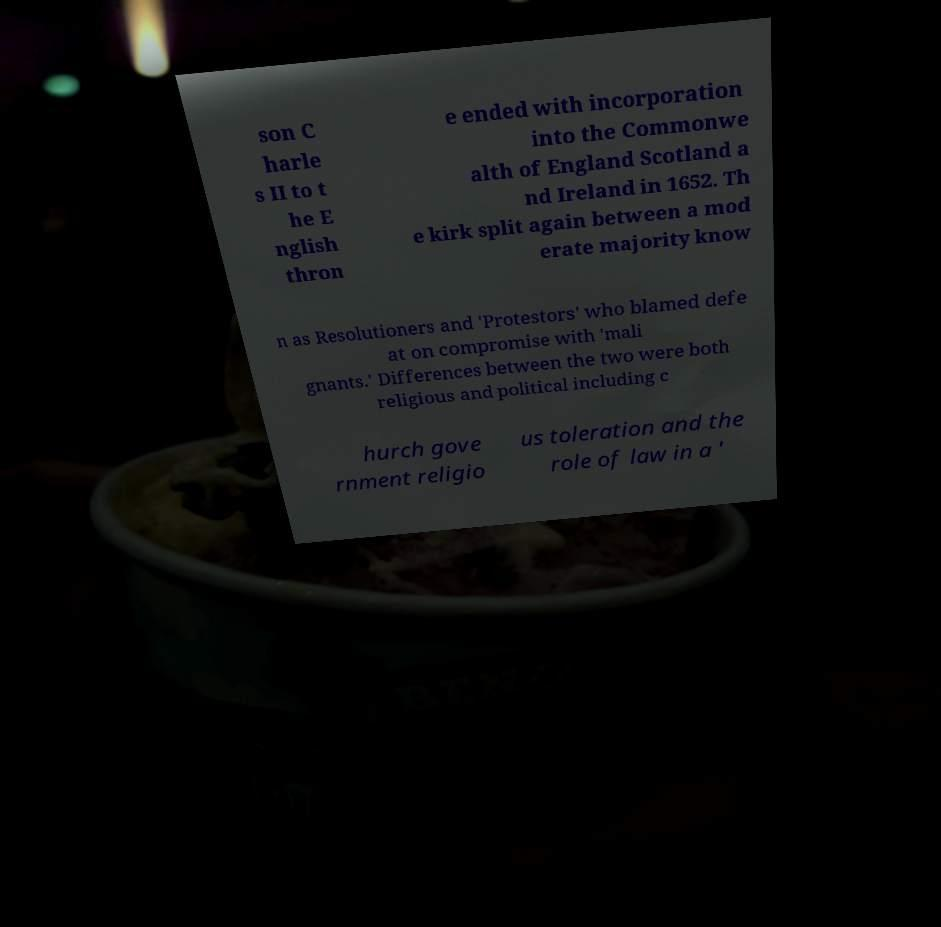There's text embedded in this image that I need extracted. Can you transcribe it verbatim? son C harle s II to t he E nglish thron e ended with incorporation into the Commonwe alth of England Scotland a nd Ireland in 1652. Th e kirk split again between a mod erate majority know n as Resolutioners and 'Protestors' who blamed defe at on compromise with 'mali gnants.' Differences between the two were both religious and political including c hurch gove rnment religio us toleration and the role of law in a ' 